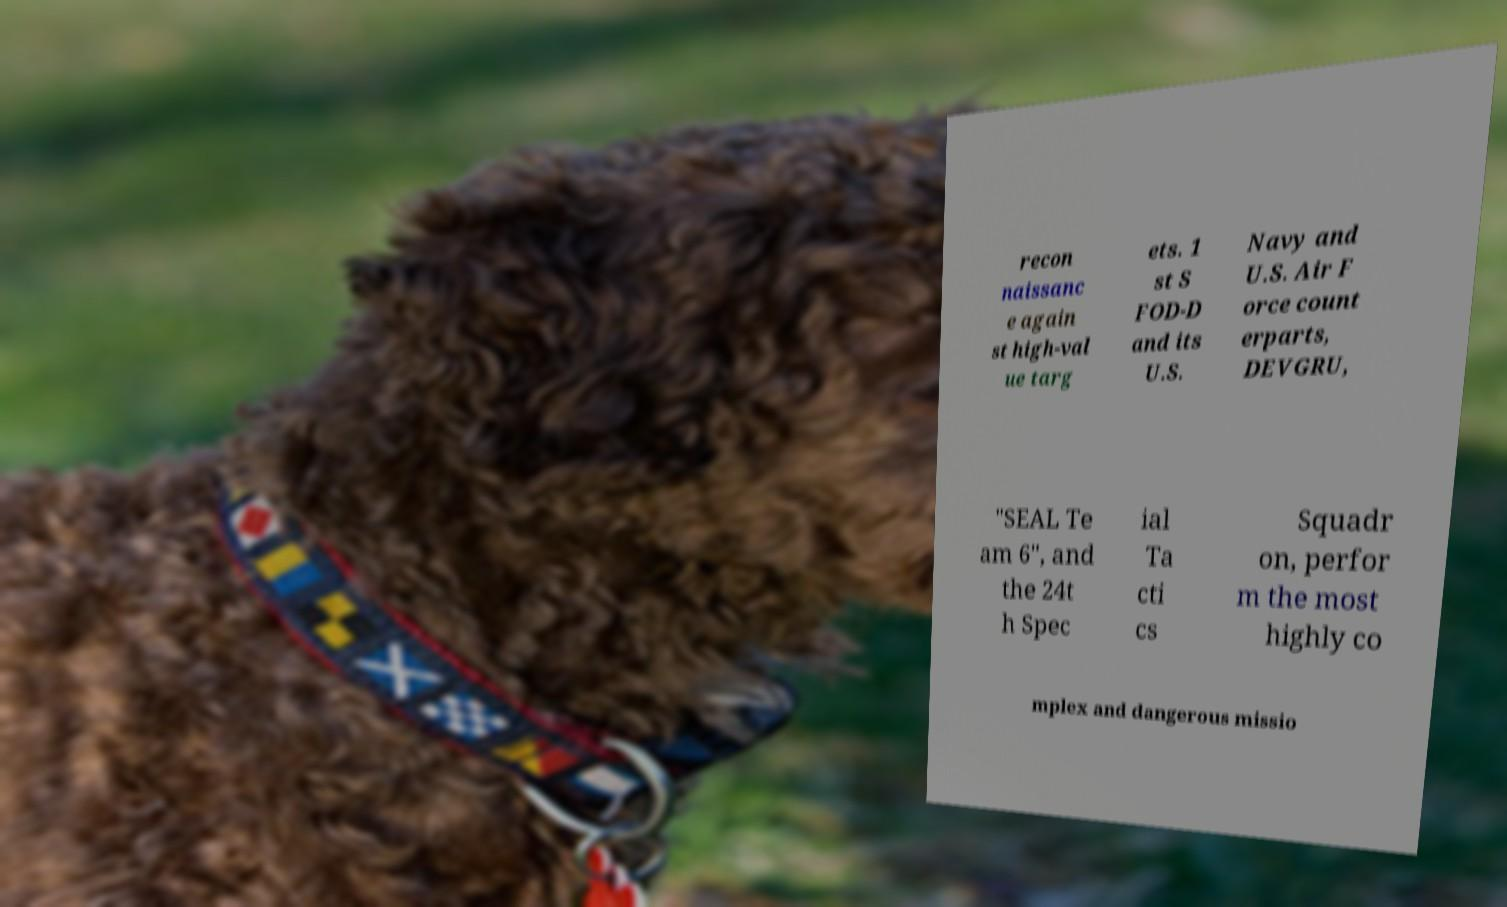Can you accurately transcribe the text from the provided image for me? recon naissanc e again st high-val ue targ ets. 1 st S FOD-D and its U.S. Navy and U.S. Air F orce count erparts, DEVGRU, "SEAL Te am 6", and the 24t h Spec ial Ta cti cs Squadr on, perfor m the most highly co mplex and dangerous missio 